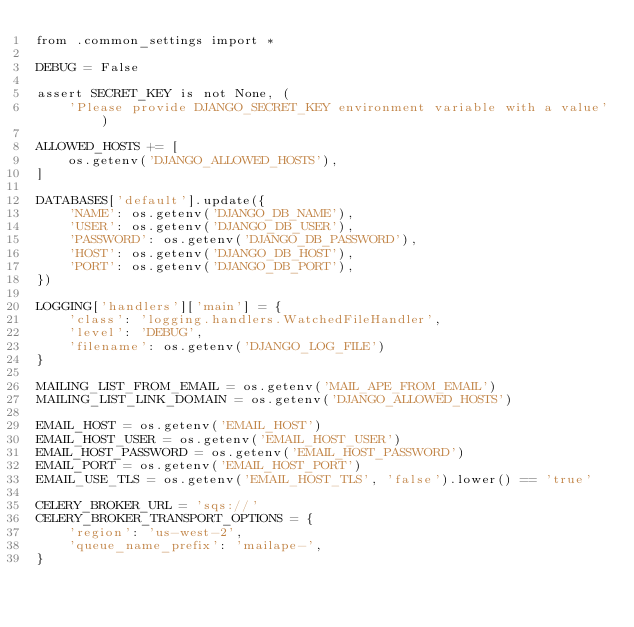Convert code to text. <code><loc_0><loc_0><loc_500><loc_500><_Python_>from .common_settings import *

DEBUG = False

assert SECRET_KEY is not None, (
    'Please provide DJANGO_SECRET_KEY environment variable with a value')

ALLOWED_HOSTS += [
    os.getenv('DJANGO_ALLOWED_HOSTS'),
]

DATABASES['default'].update({
    'NAME': os.getenv('DJANGO_DB_NAME'),
    'USER': os.getenv('DJANGO_DB_USER'),
    'PASSWORD': os.getenv('DJANGO_DB_PASSWORD'),
    'HOST': os.getenv('DJANGO_DB_HOST'),
    'PORT': os.getenv('DJANGO_DB_PORT'),
})

LOGGING['handlers']['main'] = {
    'class': 'logging.handlers.WatchedFileHandler',
    'level': 'DEBUG',
    'filename': os.getenv('DJANGO_LOG_FILE')
}

MAILING_LIST_FROM_EMAIL = os.getenv('MAIL_APE_FROM_EMAIL')
MAILING_LIST_LINK_DOMAIN = os.getenv('DJANGO_ALLOWED_HOSTS')

EMAIL_HOST = os.getenv('EMAIL_HOST')
EMAIL_HOST_USER = os.getenv('EMAIL_HOST_USER')
EMAIL_HOST_PASSWORD = os.getenv('EMAIL_HOST_PASSWORD')
EMAIL_PORT = os.getenv('EMAIL_HOST_PORT')
EMAIL_USE_TLS = os.getenv('EMAIL_HOST_TLS', 'false').lower() == 'true'

CELERY_BROKER_URL = 'sqs://'
CELERY_BROKER_TRANSPORT_OPTIONS = {
    'region': 'us-west-2',
    'queue_name_prefix': 'mailape-',
}
</code> 